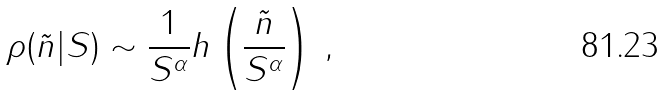<formula> <loc_0><loc_0><loc_500><loc_500>\rho ( \tilde { n } | S ) \sim \frac { 1 } { S ^ { \alpha } } h \left ( \frac { \tilde { n } } { S ^ { \alpha } } \right ) \, ,</formula> 